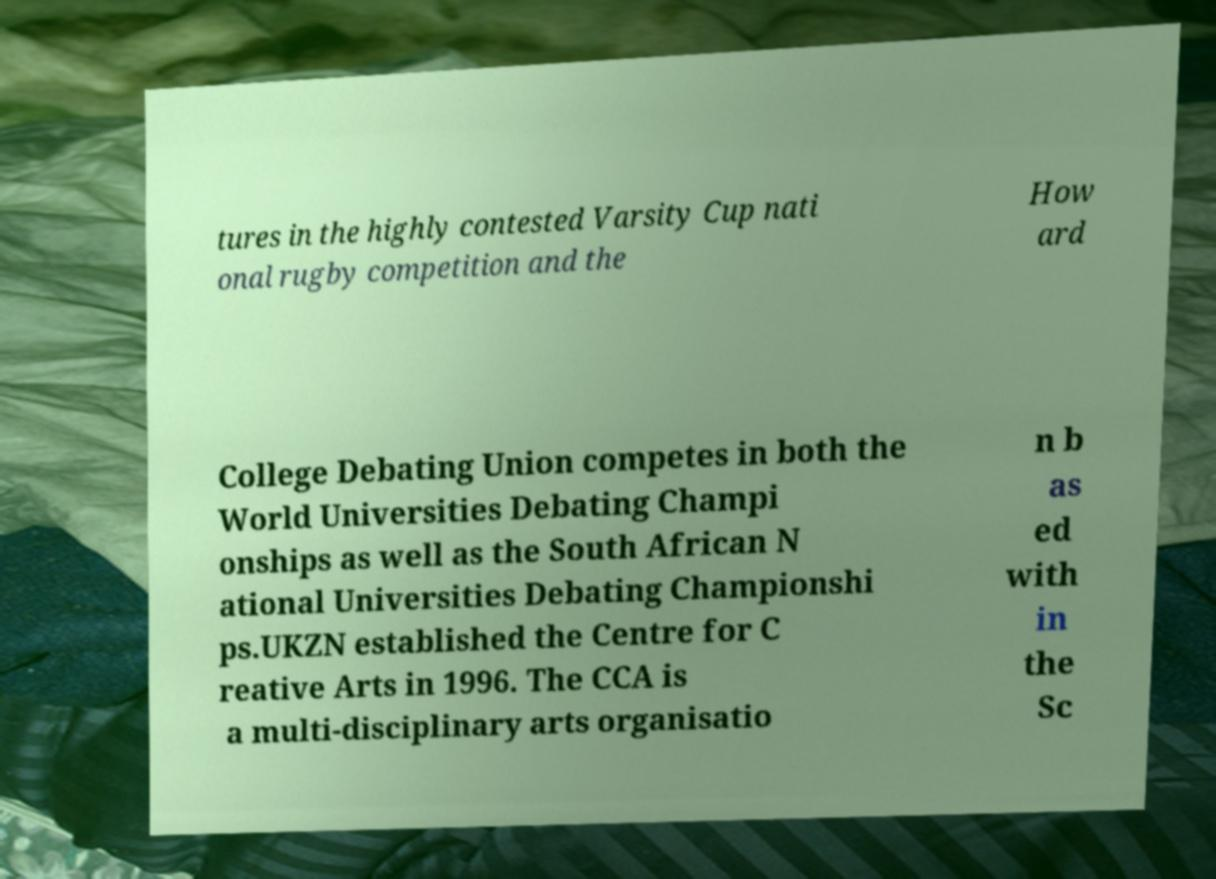Please read and relay the text visible in this image. What does it say? tures in the highly contested Varsity Cup nati onal rugby competition and the How ard College Debating Union competes in both the World Universities Debating Champi onships as well as the South African N ational Universities Debating Championshi ps.UKZN established the Centre for C reative Arts in 1996. The CCA is a multi-disciplinary arts organisatio n b as ed with in the Sc 